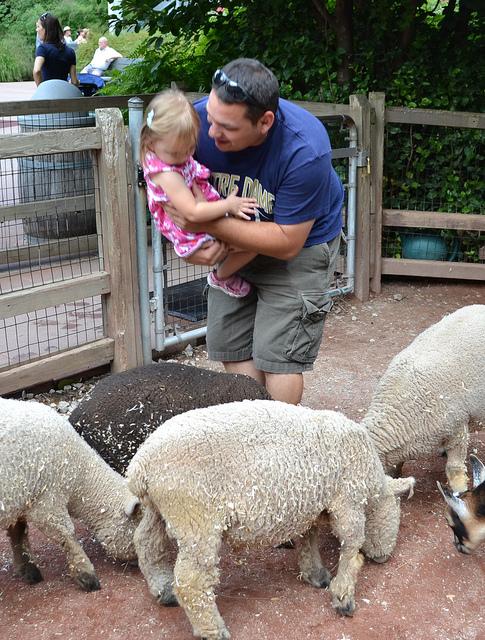Is the child petting the sheep?
Concise answer only. No. How many white sheep is there?
Give a very brief answer. 3. Why did the man bring the child into the pen?
Answer briefly. To pet sheep. 